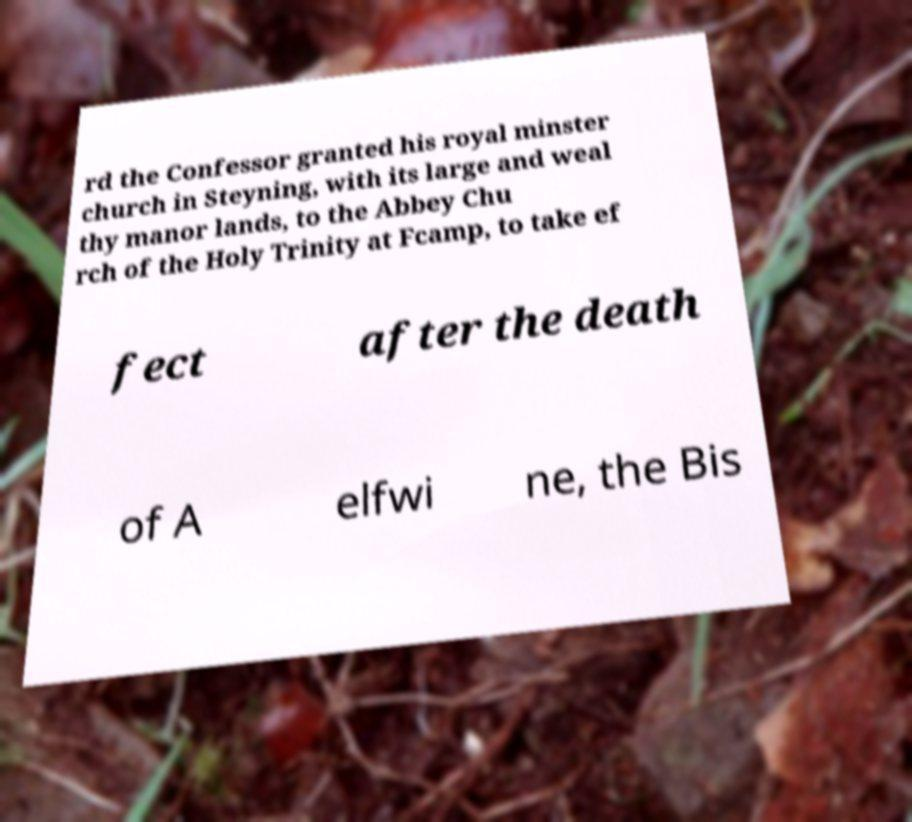I need the written content from this picture converted into text. Can you do that? rd the Confessor granted his royal minster church in Steyning, with its large and weal thy manor lands, to the Abbey Chu rch of the Holy Trinity at Fcamp, to take ef fect after the death of A elfwi ne, the Bis 